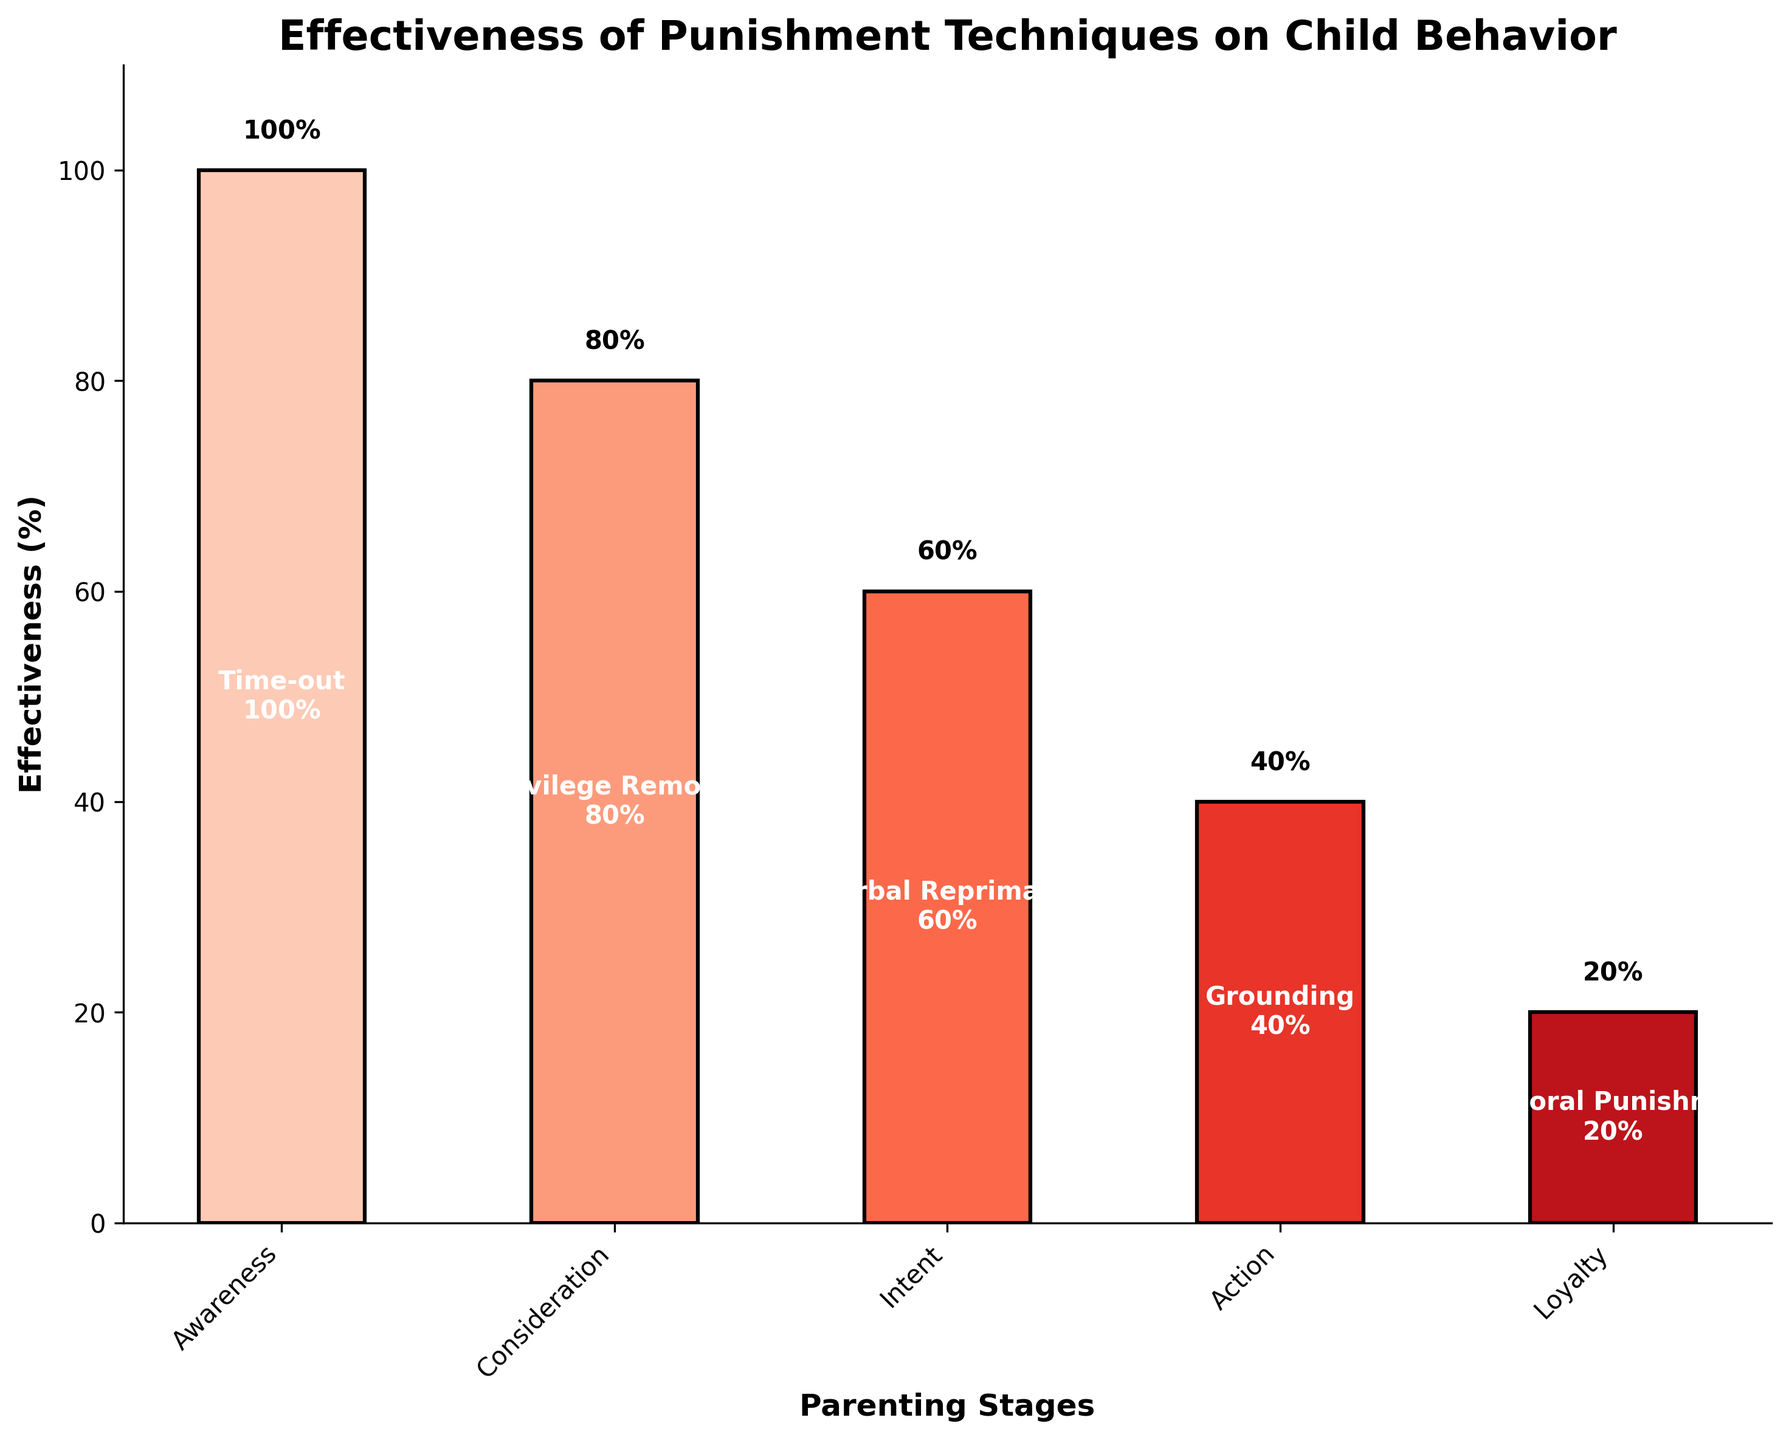What is the title of the figure? The title is located at the top of the figure and provides a concise description of what the figure represents.
Answer: Effectiveness of Punishment Techniques on Child Behavior How many punishment techniques are shown in the chart? By counting the different labels under the "Technique" category, you can identify the number of techniques displayed.
Answer: Five What parenting stage has the highest effectiveness percentage? Compare the effectiveness percentages for each parenting stage and find the one with the highest value.
Answer: Time-out Which technique has the lowest effectiveness percentage? Look at the effectiveness percentages and identify which value is the lowest.
Answer: Corporal Punishment What is the effectiveness of verbal reprimand? Locate the "Verbal Reprimand" label and read the corresponding effectiveness percentage.
Answer: 60% How much more effective is privilege removal compared to grounding? Subtract the effectiveness percentage of grounding from that of privilege removal (80% - 40%).
Answer: 40% What is the difference between the effectiveness of time-out and corporal punishment? Subtract the effectiveness percentage of corporal punishment from that of time-out (100% - 20%).
Answer: 80% On average, how effective are the punishment techniques shown? Add up all the effectiveness percentages (100 + 80 + 60 + 40 + 20) and divide by the number of techniques (5).
Answer: 60% Which parenting stage follows privilege removal in terms of effectiveness? Identify the stage associated with privilege removal and locate the next stage in terms of decreasing effectiveness.
Answer: Verbal Reprimand Is privilege removal more effective than grounding and corporal punishment combined? Add the effectiveness percentages of grounding and corporal punishment (40% + 20%) and compare with the effectiveness of privilege removal (80%).
Answer: Yes, 80% is more than 60% 